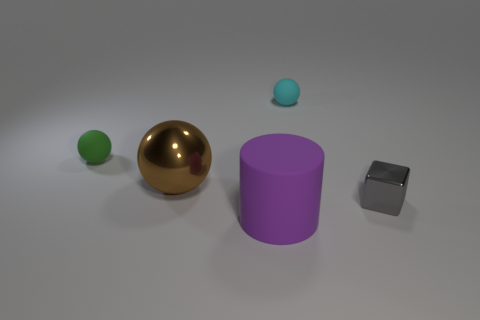Add 1 large cyan metal blocks. How many objects exist? 6 Subtract all cubes. How many objects are left? 4 Add 1 small cyan spheres. How many small cyan spheres are left? 2 Add 2 tiny cyan matte spheres. How many tiny cyan matte spheres exist? 3 Subtract 0 purple blocks. How many objects are left? 5 Subtract all gray metal spheres. Subtract all brown shiny spheres. How many objects are left? 4 